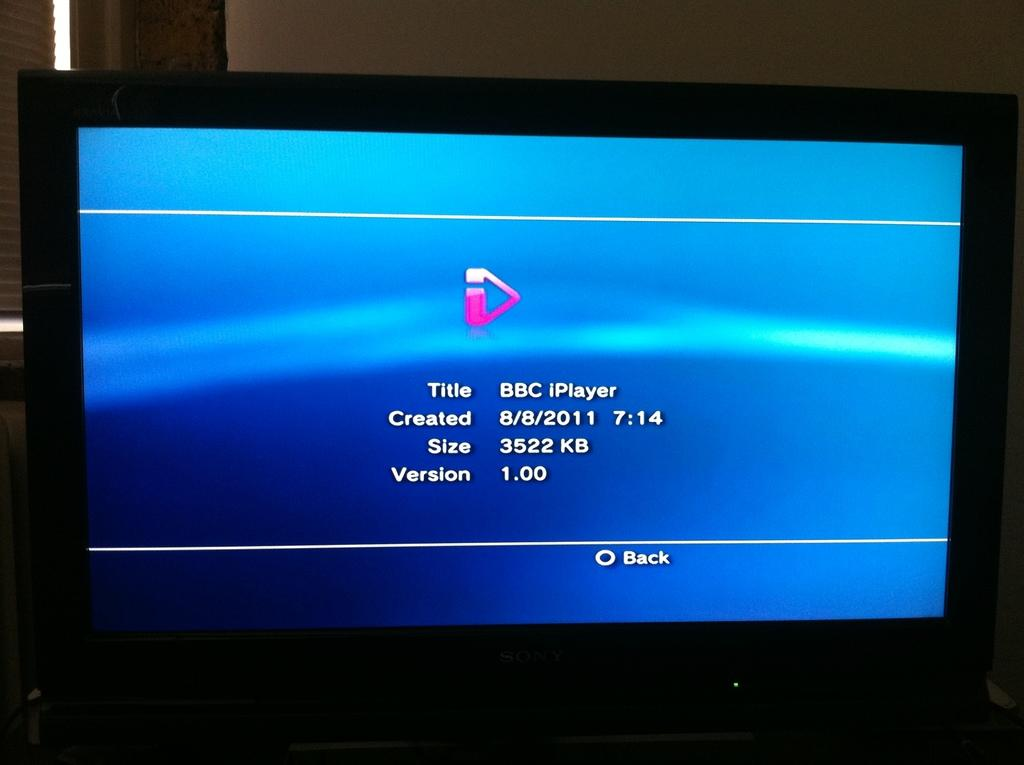<image>
Present a compact description of the photo's key features. A tv monitor displays details about a file that is 3522 kb in size. 